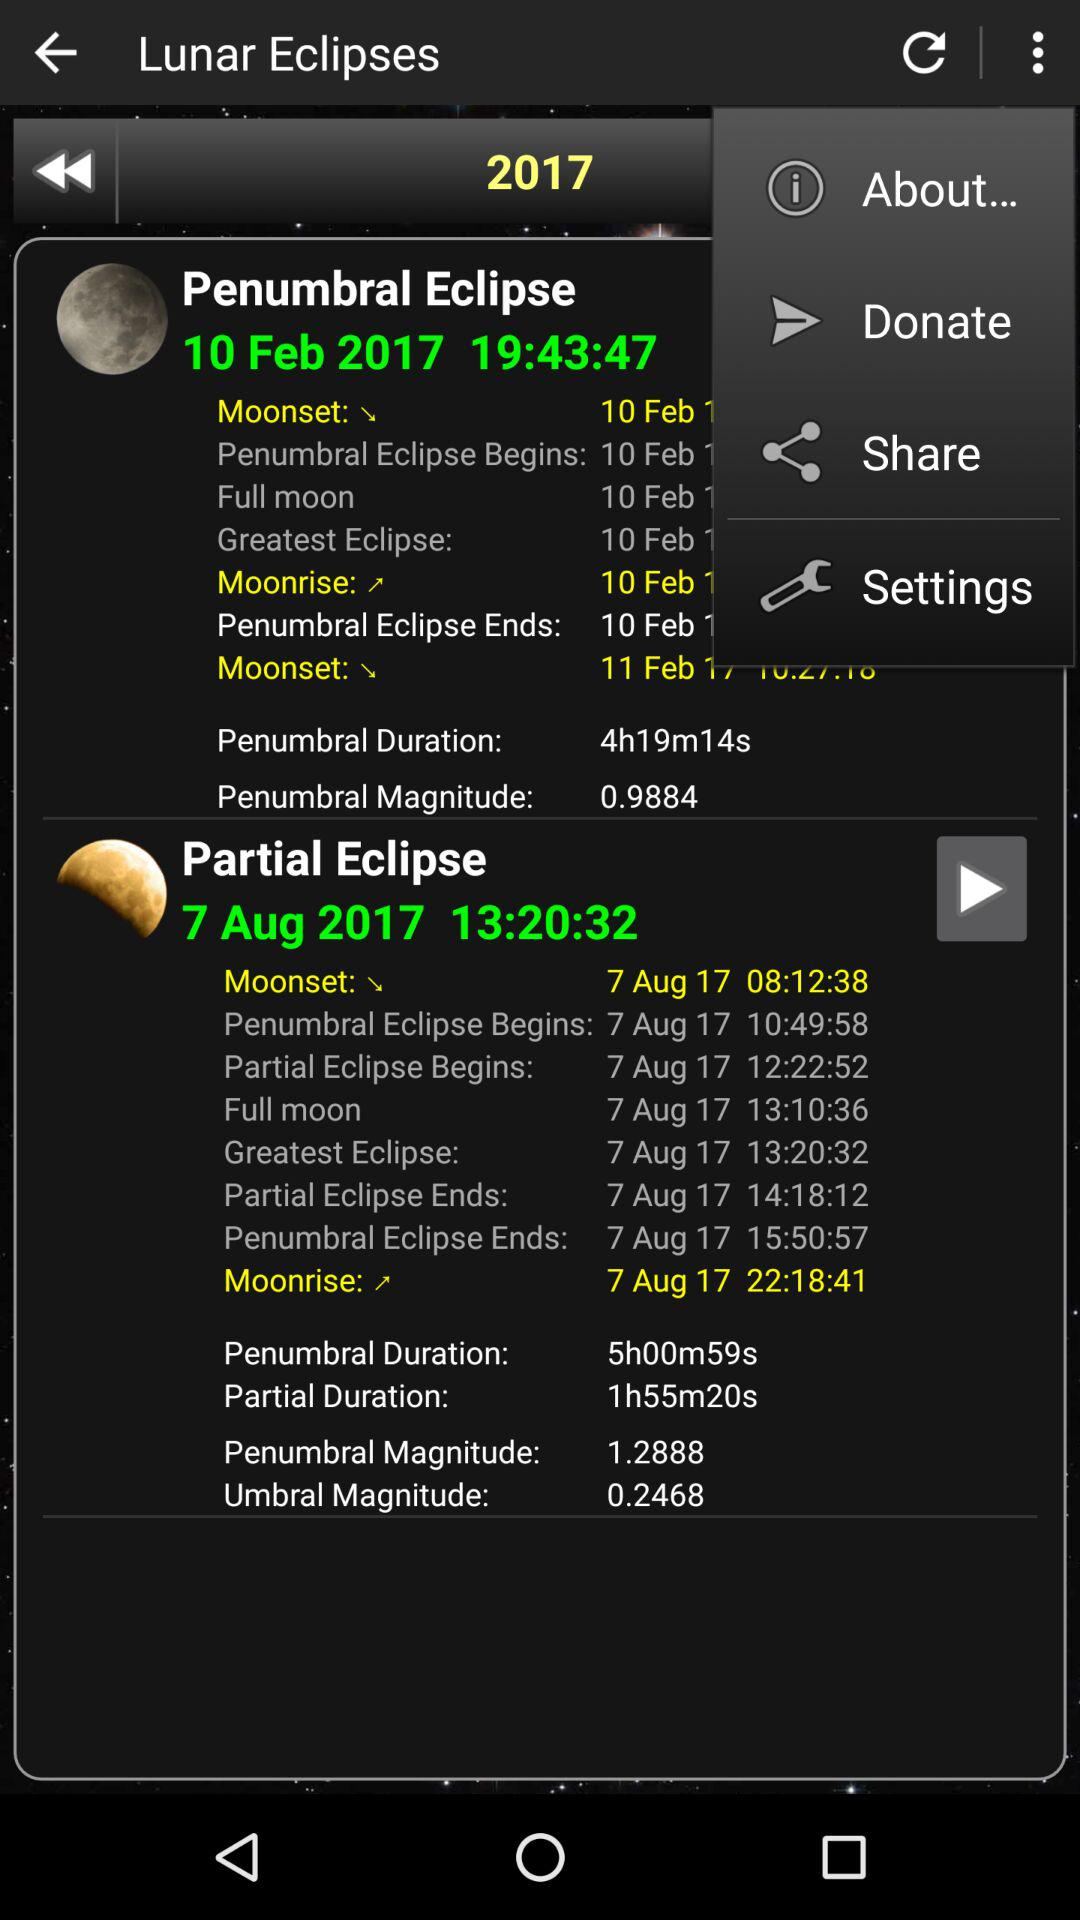What is the date of penumbral eclipse? The date is 10 Feb 2017. 